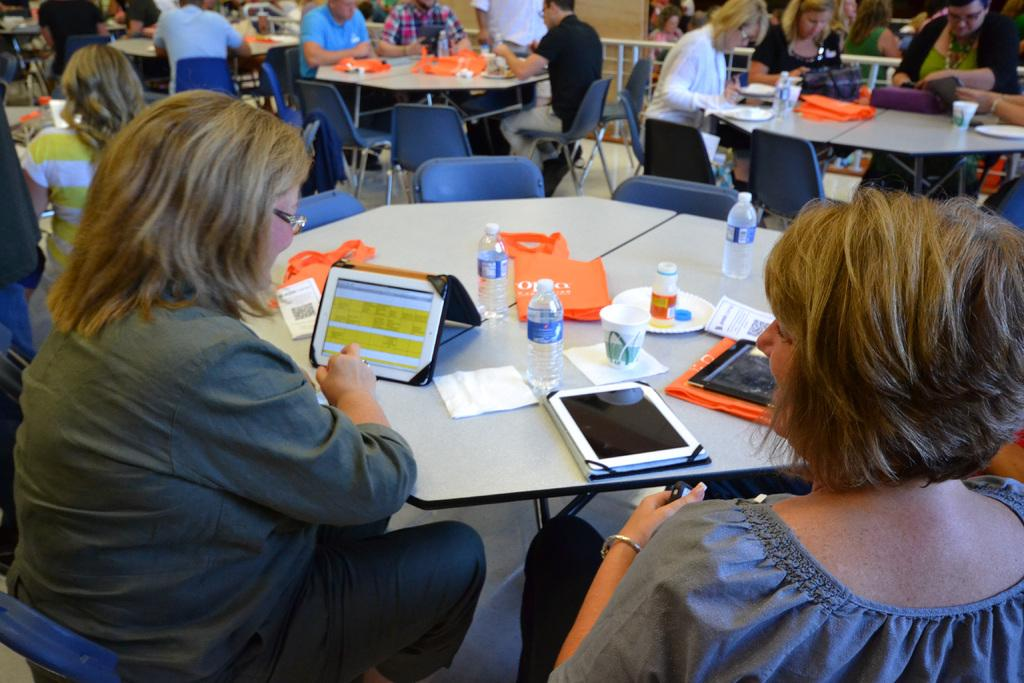What is the main subject of the image? The main subject of the image is a group of people. What are the people doing in the image? The people are sitting on chairs in the image. What can be seen on the tables in the image? There are items placed on the tables in the image. What is visible at the top of the image? There are rods visible at the top of the image. What type of division is taking place among the people in the image? There is no indication of any division among the people in the image; they are simply sitting on chairs. What knowledge is being shared among the people in the image? There is no indication of any knowledge being shared among the people in the image; they are just sitting on chairs. 